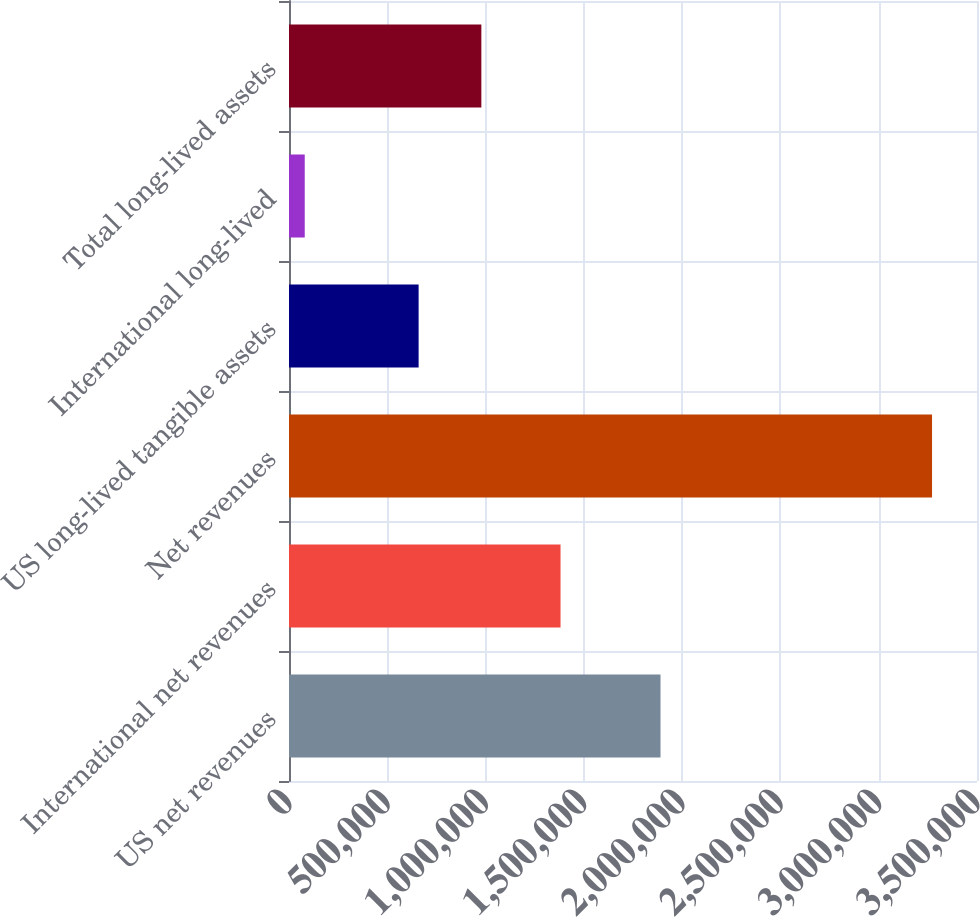<chart> <loc_0><loc_0><loc_500><loc_500><bar_chart><fcel>US net revenues<fcel>International net revenues<fcel>Net revenues<fcel>US long-lived tangible assets<fcel>International long-lived<fcel>Total long-lived assets<nl><fcel>1.88994e+06<fcel>1.38137e+06<fcel>3.27131e+06<fcel>659423<fcel>80069<fcel>978547<nl></chart> 